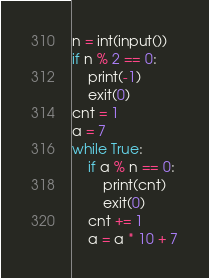Convert code to text. <code><loc_0><loc_0><loc_500><loc_500><_Python_>n = int(input())
if n % 2 == 0:
	print(-1)
	exit(0)
cnt = 1
a = 7
while True:
	if a % n == 0:
		print(cnt)
		exit(0)
	cnt += 1
	a = a * 10 + 7
</code> 